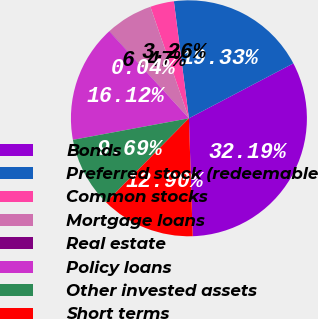<chart> <loc_0><loc_0><loc_500><loc_500><pie_chart><fcel>Bonds<fcel>Preferred stock (redeemable<fcel>Common stocks<fcel>Mortgage loans<fcel>Real estate<fcel>Policy loans<fcel>Other invested assets<fcel>Short terms<nl><fcel>32.19%<fcel>19.33%<fcel>3.26%<fcel>6.47%<fcel>0.04%<fcel>16.12%<fcel>9.69%<fcel>12.9%<nl></chart> 